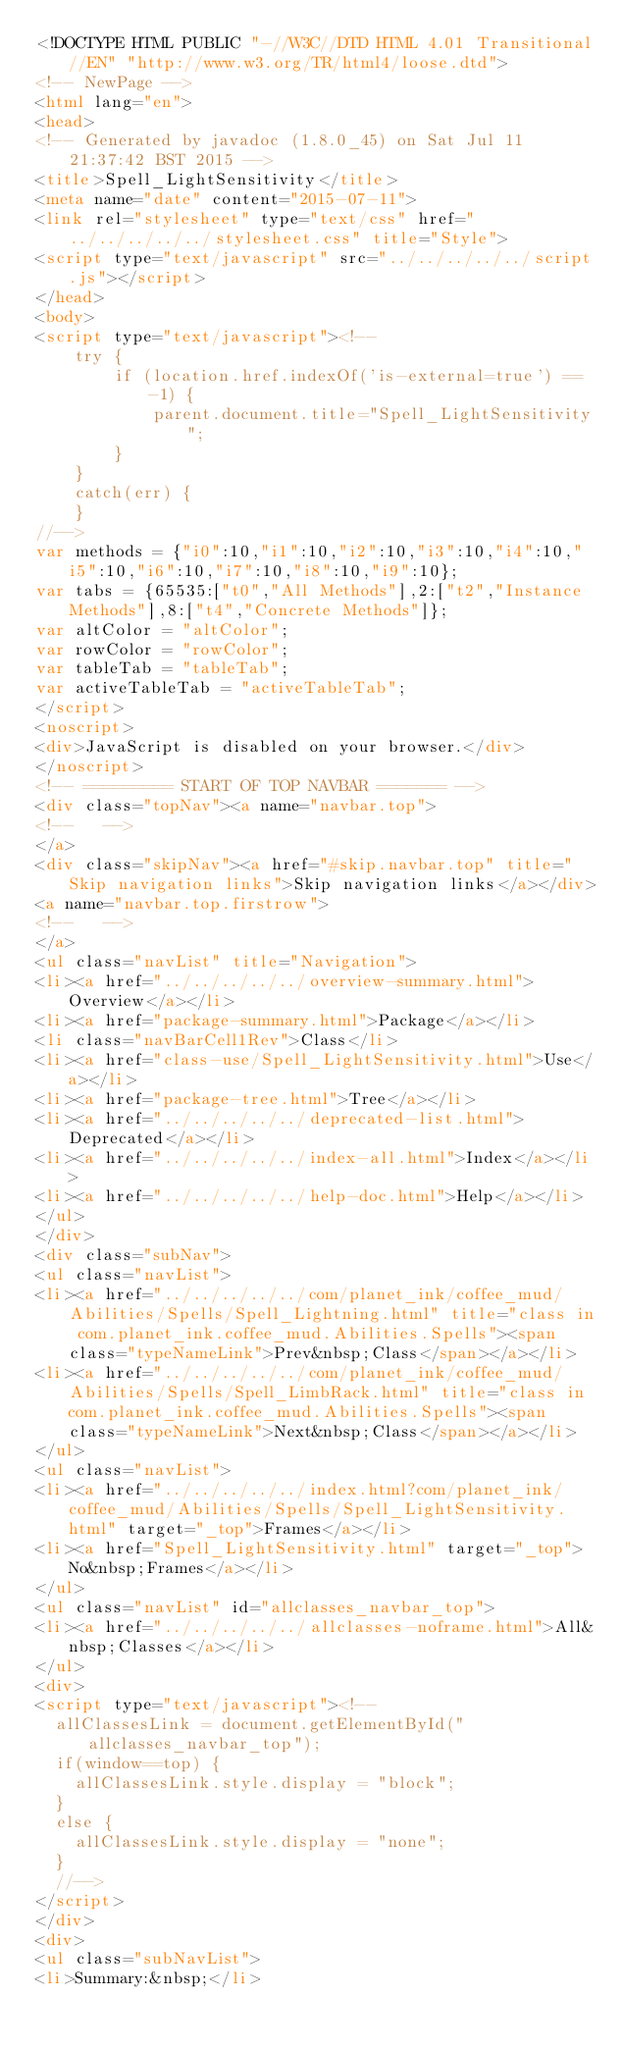Convert code to text. <code><loc_0><loc_0><loc_500><loc_500><_HTML_><!DOCTYPE HTML PUBLIC "-//W3C//DTD HTML 4.01 Transitional//EN" "http://www.w3.org/TR/html4/loose.dtd">
<!-- NewPage -->
<html lang="en">
<head>
<!-- Generated by javadoc (1.8.0_45) on Sat Jul 11 21:37:42 BST 2015 -->
<title>Spell_LightSensitivity</title>
<meta name="date" content="2015-07-11">
<link rel="stylesheet" type="text/css" href="../../../../../stylesheet.css" title="Style">
<script type="text/javascript" src="../../../../../script.js"></script>
</head>
<body>
<script type="text/javascript"><!--
    try {
        if (location.href.indexOf('is-external=true') == -1) {
            parent.document.title="Spell_LightSensitivity";
        }
    }
    catch(err) {
    }
//-->
var methods = {"i0":10,"i1":10,"i2":10,"i3":10,"i4":10,"i5":10,"i6":10,"i7":10,"i8":10,"i9":10};
var tabs = {65535:["t0","All Methods"],2:["t2","Instance Methods"],8:["t4","Concrete Methods"]};
var altColor = "altColor";
var rowColor = "rowColor";
var tableTab = "tableTab";
var activeTableTab = "activeTableTab";
</script>
<noscript>
<div>JavaScript is disabled on your browser.</div>
</noscript>
<!-- ========= START OF TOP NAVBAR ======= -->
<div class="topNav"><a name="navbar.top">
<!--   -->
</a>
<div class="skipNav"><a href="#skip.navbar.top" title="Skip navigation links">Skip navigation links</a></div>
<a name="navbar.top.firstrow">
<!--   -->
</a>
<ul class="navList" title="Navigation">
<li><a href="../../../../../overview-summary.html">Overview</a></li>
<li><a href="package-summary.html">Package</a></li>
<li class="navBarCell1Rev">Class</li>
<li><a href="class-use/Spell_LightSensitivity.html">Use</a></li>
<li><a href="package-tree.html">Tree</a></li>
<li><a href="../../../../../deprecated-list.html">Deprecated</a></li>
<li><a href="../../../../../index-all.html">Index</a></li>
<li><a href="../../../../../help-doc.html">Help</a></li>
</ul>
</div>
<div class="subNav">
<ul class="navList">
<li><a href="../../../../../com/planet_ink/coffee_mud/Abilities/Spells/Spell_Lightning.html" title="class in com.planet_ink.coffee_mud.Abilities.Spells"><span class="typeNameLink">Prev&nbsp;Class</span></a></li>
<li><a href="../../../../../com/planet_ink/coffee_mud/Abilities/Spells/Spell_LimbRack.html" title="class in com.planet_ink.coffee_mud.Abilities.Spells"><span class="typeNameLink">Next&nbsp;Class</span></a></li>
</ul>
<ul class="navList">
<li><a href="../../../../../index.html?com/planet_ink/coffee_mud/Abilities/Spells/Spell_LightSensitivity.html" target="_top">Frames</a></li>
<li><a href="Spell_LightSensitivity.html" target="_top">No&nbsp;Frames</a></li>
</ul>
<ul class="navList" id="allclasses_navbar_top">
<li><a href="../../../../../allclasses-noframe.html">All&nbsp;Classes</a></li>
</ul>
<div>
<script type="text/javascript"><!--
  allClassesLink = document.getElementById("allclasses_navbar_top");
  if(window==top) {
    allClassesLink.style.display = "block";
  }
  else {
    allClassesLink.style.display = "none";
  }
  //-->
</script>
</div>
<div>
<ul class="subNavList">
<li>Summary:&nbsp;</li></code> 